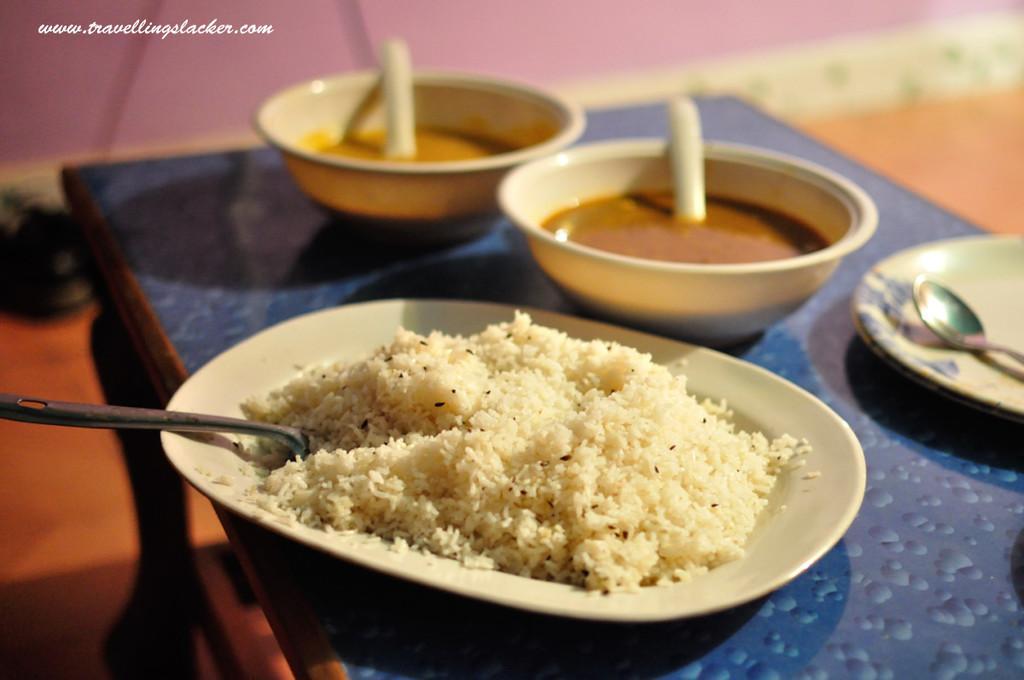Describe this image in one or two sentences. In this image there are 2 bowls, 2 plates , food, 2 spoons in table. 